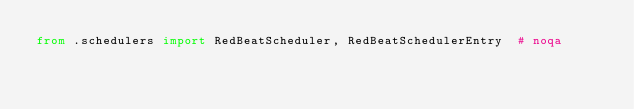Convert code to text. <code><loc_0><loc_0><loc_500><loc_500><_Python_>from .schedulers import RedBeatScheduler, RedBeatSchedulerEntry  # noqa
</code> 